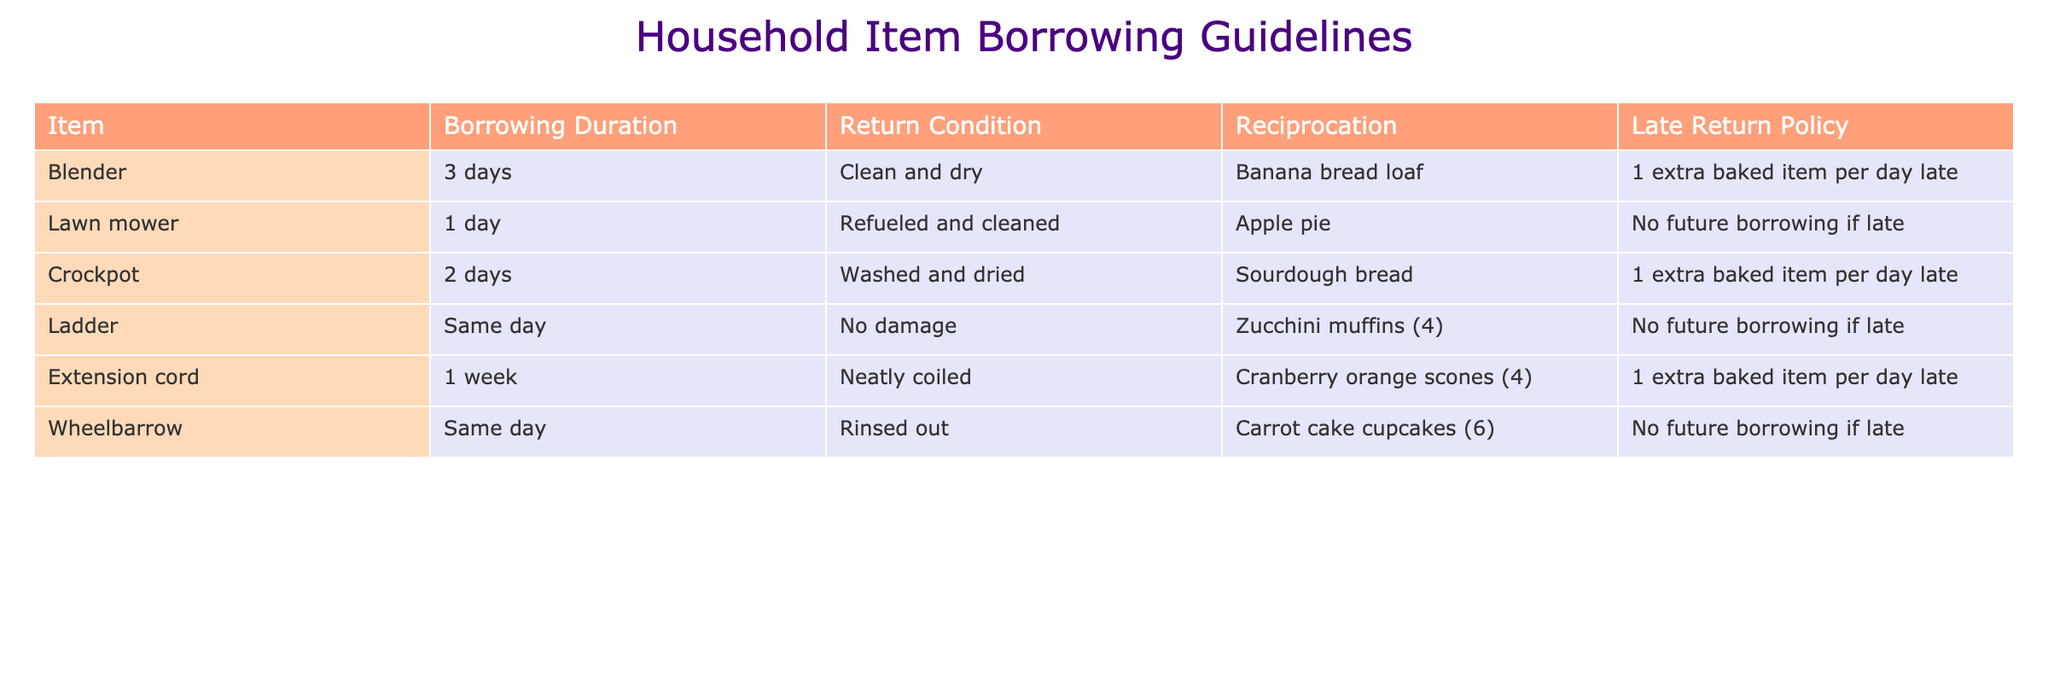What is the borrowing duration for a blender? The table states that the borrowing duration for a blender is 3 days, which is listed in the 'Borrowing Duration' column.
Answer: 3 days What should the condition be for returning the lawn mower? According to the table, the lawn mower should be returned 'Refueled and cleaned' as mentioned in the 'Return Condition' column.
Answer: Refueled and cleaned If I return the crockpot late by two days, how many extra baked items do I need to provide? The policy for the crockpot indicates that for each day late, I need to provide 1 extra baked item. Being late by two days means I would owe 2 extra items, resulting in a total of 2 extras.
Answer: 2 extra baked items Can I borrow the ladder if I return it damaged? The table indicates that the ladder must be returned with 'No damage' in the 'Return Condition' column, so returning it damaged would indeed preclude borrowing again in the future.
Answer: No What is the total number of baked goods expected if I borrow the extension cord for one week and return it late by three days? The table specifies that for the extension cord, I need to bring 4 cranberry orange scones as reciprocation. Additionally, for being 3 days late, I owe 3 extra baked items (1 per day late). Therefore, the total is 4 + 3 = 7 baked goods owed.
Answer: 7 baked goods Is it true that borrowing the wheelbarrow will prohibit future borrowing if returned late? Yes, the table states that the wheelbarrow cannot be borrowed again if it is returned late, which is noted in the 'Late Return Policy' section related to the wheelbarrow.
Answer: Yes How many baked items do I need to reciprocate if I borrow the ladder for the same day and return it on time? Since the ladder must be returned on the same day and no late return implies no extra items, if I return it on time, I owe only the initial expected items listed which are 4 zucchini muffins. So, the total remains 4.
Answer: 4 zucchini muffins What are the borrowing conditions for the items that allow for a lending period of 1 day? Two items have a borrowing duration of 1 day: the lawn mower and the ladder. The lawn mower must be returned 'Refueled and cleaned', while the ladder must be returned with 'No damage'.
Answer: Lawn mower: Refueled and cleaned, Ladder: No damage If I want to bake banana bread to reciprocate for borrowing the blender, how long can I keep it before returning? The borrowing duration for the blender is 3 days, so I can keep it for that length before returning it, as per the guidelines in the table.
Answer: 3 days 